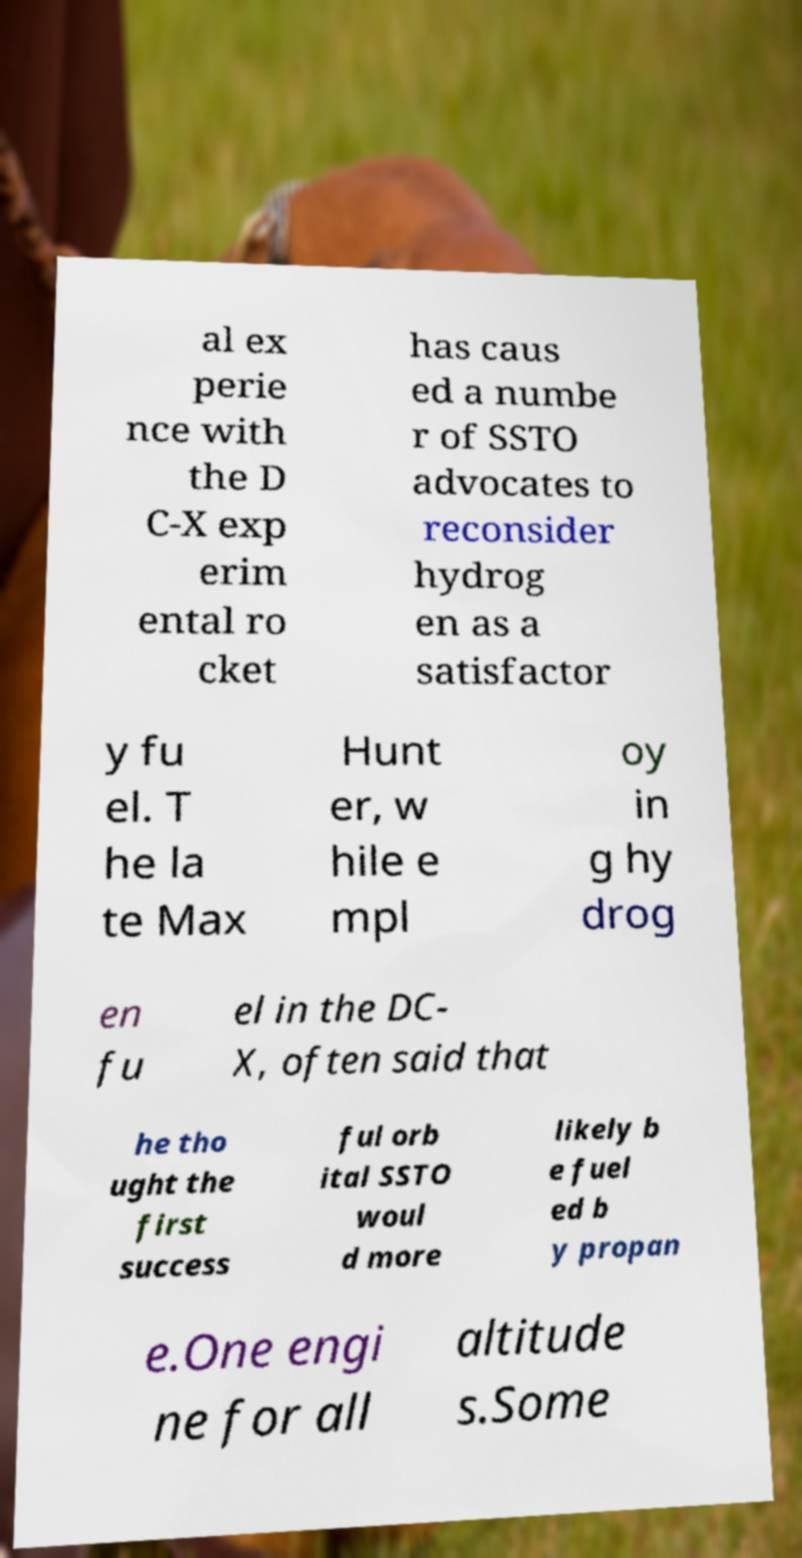For documentation purposes, I need the text within this image transcribed. Could you provide that? al ex perie nce with the D C-X exp erim ental ro cket has caus ed a numbe r of SSTO advocates to reconsider hydrog en as a satisfactor y fu el. T he la te Max Hunt er, w hile e mpl oy in g hy drog en fu el in the DC- X, often said that he tho ught the first success ful orb ital SSTO woul d more likely b e fuel ed b y propan e.One engi ne for all altitude s.Some 